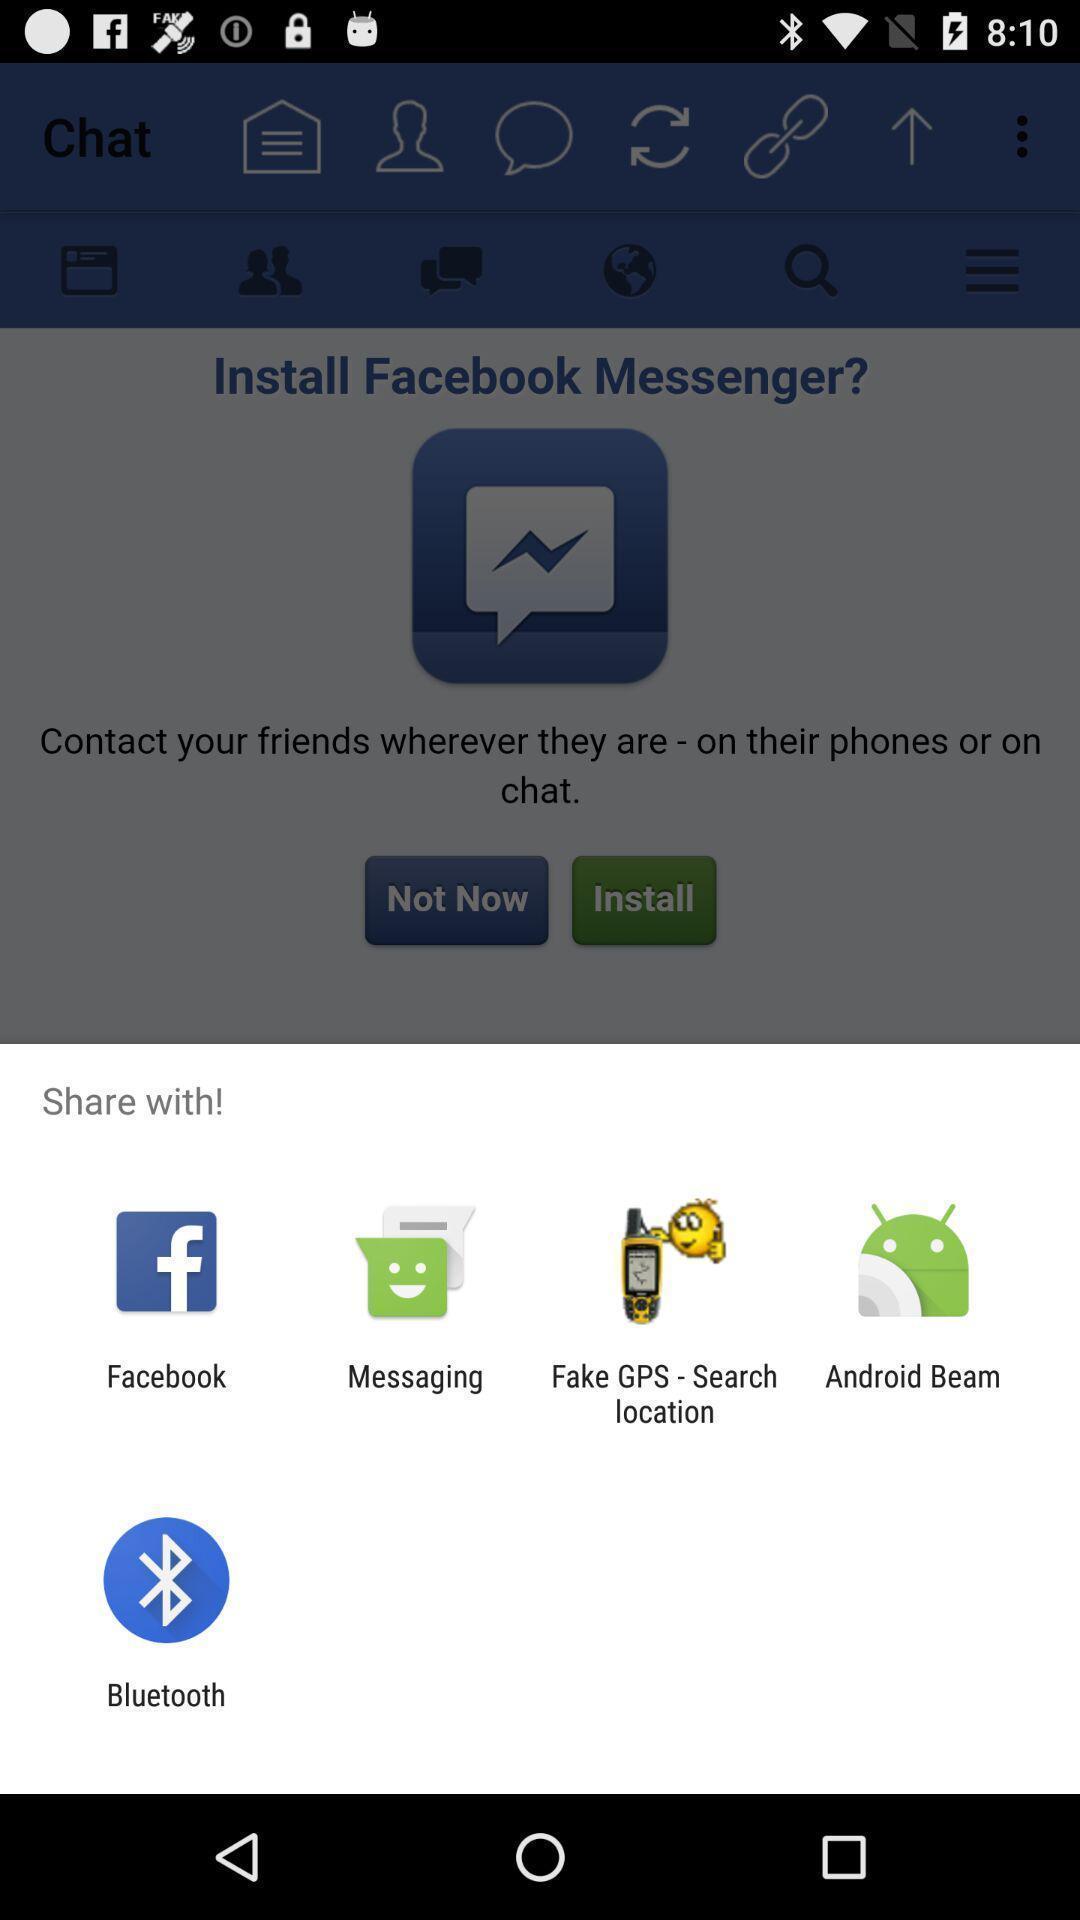Summarize the information in this screenshot. Share with options page of a social app. 